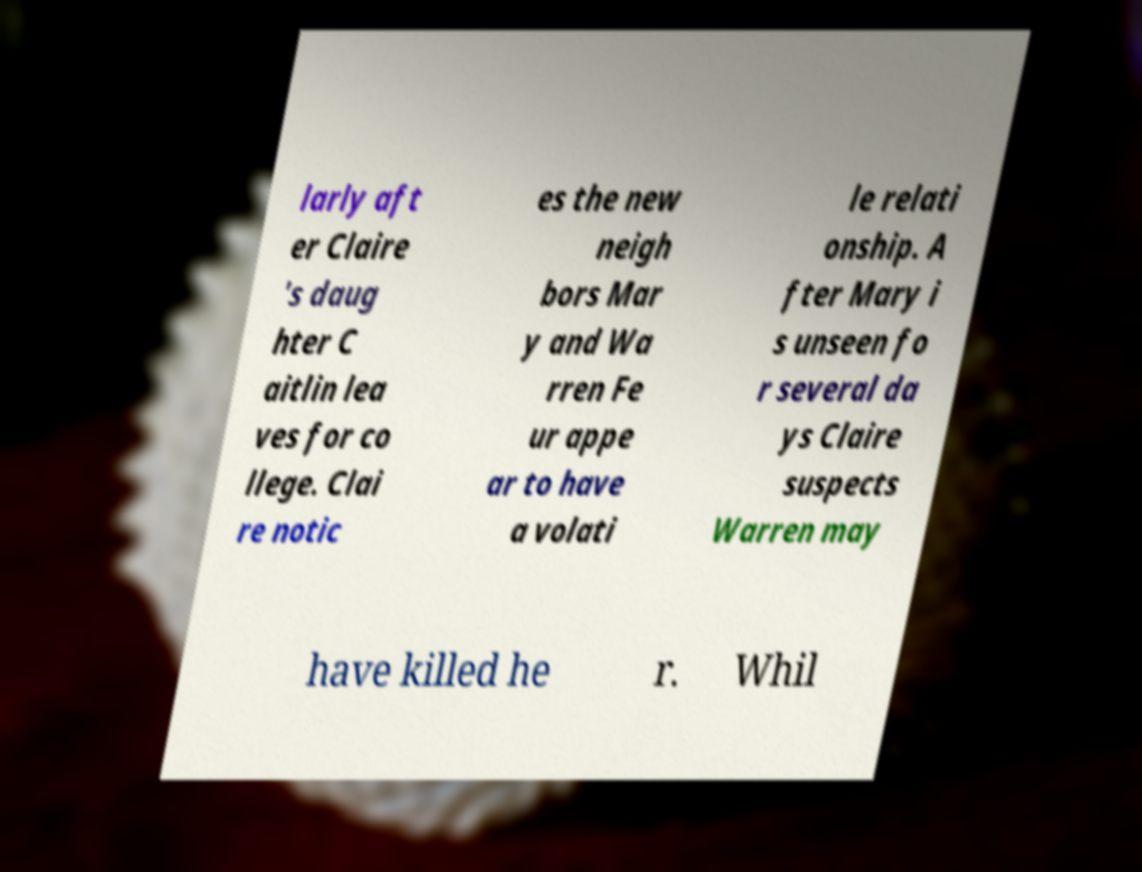There's text embedded in this image that I need extracted. Can you transcribe it verbatim? larly aft er Claire 's daug hter C aitlin lea ves for co llege. Clai re notic es the new neigh bors Mar y and Wa rren Fe ur appe ar to have a volati le relati onship. A fter Mary i s unseen fo r several da ys Claire suspects Warren may have killed he r. Whil 